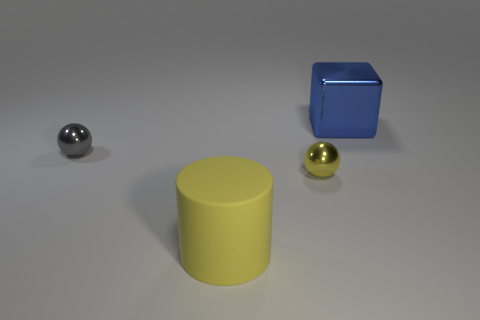Are there any other things that are the same material as the cylinder?
Make the answer very short. No. Is the yellow cylinder made of the same material as the blue cube?
Provide a short and direct response. No. What number of small spheres are on the right side of the large yellow thing that is in front of the gray object?
Provide a succinct answer. 1. What number of other objects are the same size as the yellow metallic sphere?
Your response must be concise. 1. What number of objects are yellow metallic things or tiny metal balls that are to the right of the large yellow object?
Your answer should be compact. 1. Are there fewer big brown metallic spheres than big yellow objects?
Your answer should be compact. Yes. What color is the metal sphere to the left of the large object that is in front of the blue cube?
Make the answer very short. Gray. There is another object that is the same shape as the tiny yellow object; what is it made of?
Offer a terse response. Metal. How many rubber objects are either big yellow things or big things?
Provide a short and direct response. 1. Is the material of the tiny object behind the tiny yellow shiny thing the same as the large thing left of the blue block?
Provide a succinct answer. No. 